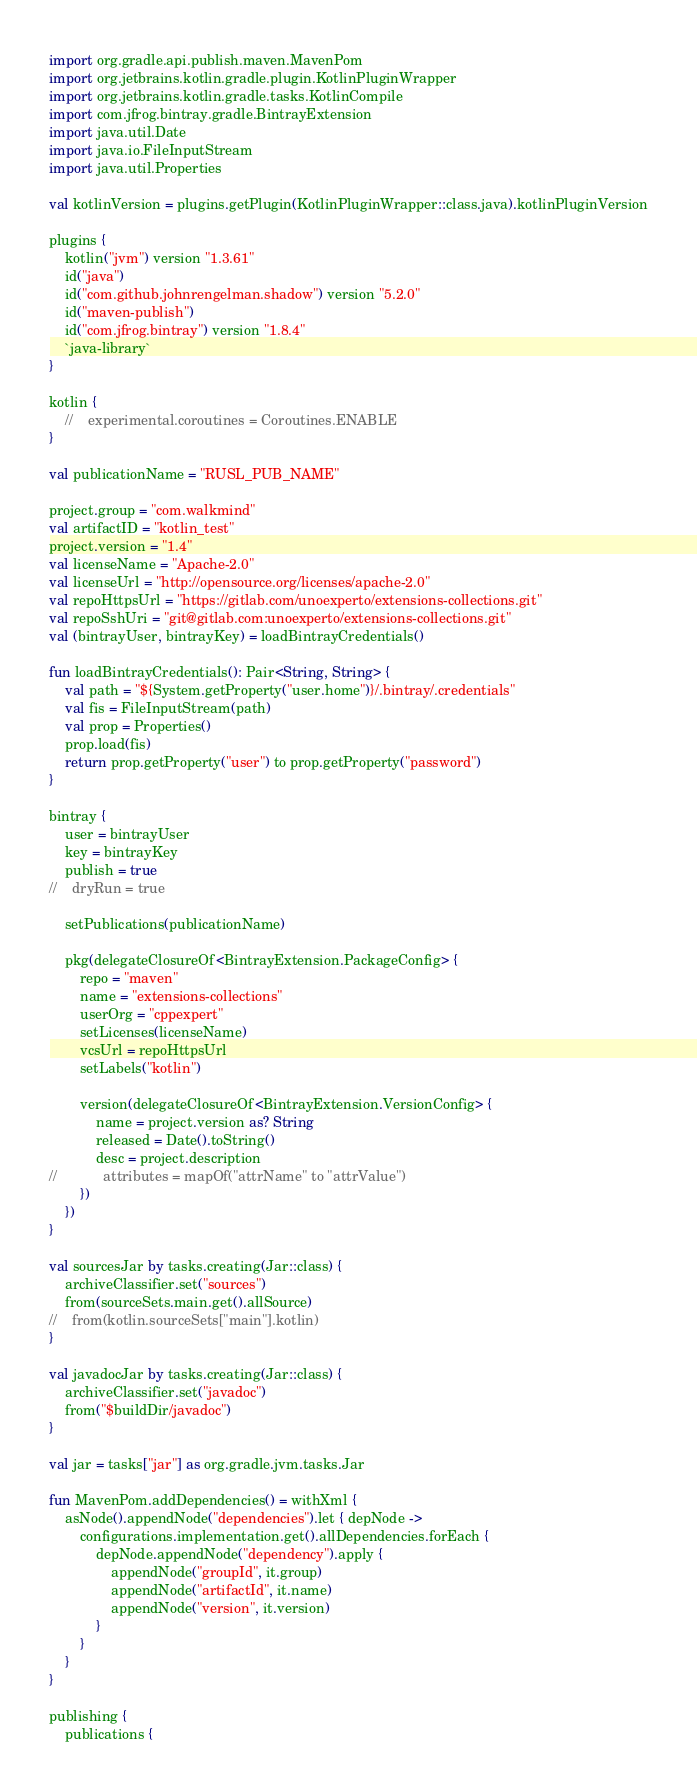Convert code to text. <code><loc_0><loc_0><loc_500><loc_500><_Kotlin_>import org.gradle.api.publish.maven.MavenPom
import org.jetbrains.kotlin.gradle.plugin.KotlinPluginWrapper
import org.jetbrains.kotlin.gradle.tasks.KotlinCompile
import com.jfrog.bintray.gradle.BintrayExtension
import java.util.Date
import java.io.FileInputStream
import java.util.Properties

val kotlinVersion = plugins.getPlugin(KotlinPluginWrapper::class.java).kotlinPluginVersion

plugins {
    kotlin("jvm") version "1.3.61"
    id("java")
    id("com.github.johnrengelman.shadow") version "5.2.0"
    id("maven-publish")
    id("com.jfrog.bintray") version "1.8.4"
    `java-library`
}

kotlin {
    //    experimental.coroutines = Coroutines.ENABLE
}

val publicationName = "RUSL_PUB_NAME"

project.group = "com.walkmind"
val artifactID = "kotlin_test"
project.version = "1.4"
val licenseName = "Apache-2.0"
val licenseUrl = "http://opensource.org/licenses/apache-2.0"
val repoHttpsUrl = "https://gitlab.com/unoexperto/extensions-collections.git"
val repoSshUri = "git@gitlab.com:unoexperto/extensions-collections.git"
val (bintrayUser, bintrayKey) = loadBintrayCredentials()

fun loadBintrayCredentials(): Pair<String, String> {
    val path = "${System.getProperty("user.home")}/.bintray/.credentials"
    val fis = FileInputStream(path)
    val prop = Properties()
    prop.load(fis)
    return prop.getProperty("user") to prop.getProperty("password")
}

bintray {
    user = bintrayUser
    key = bintrayKey
    publish = true
//    dryRun = true

    setPublications(publicationName)

    pkg(delegateClosureOf<BintrayExtension.PackageConfig> {
        repo = "maven"
        name = "extensions-collections"
        userOrg = "cppexpert"
        setLicenses(licenseName)
        vcsUrl = repoHttpsUrl
        setLabels("kotlin")

        version(delegateClosureOf<BintrayExtension.VersionConfig> {
            name = project.version as? String
            released = Date().toString()
            desc = project.description
//            attributes = mapOf("attrName" to "attrValue")
        })
    })
}

val sourcesJar by tasks.creating(Jar::class) {
    archiveClassifier.set("sources")
    from(sourceSets.main.get().allSource)
//    from(kotlin.sourceSets["main"].kotlin)
}

val javadocJar by tasks.creating(Jar::class) {
    archiveClassifier.set("javadoc")
    from("$buildDir/javadoc")
}

val jar = tasks["jar"] as org.gradle.jvm.tasks.Jar

fun MavenPom.addDependencies() = withXml {
    asNode().appendNode("dependencies").let { depNode ->
        configurations.implementation.get().allDependencies.forEach {
            depNode.appendNode("dependency").apply {
                appendNode("groupId", it.group)
                appendNode("artifactId", it.name)
                appendNode("version", it.version)
            }
        }
    }
}

publishing {
    publications {</code> 